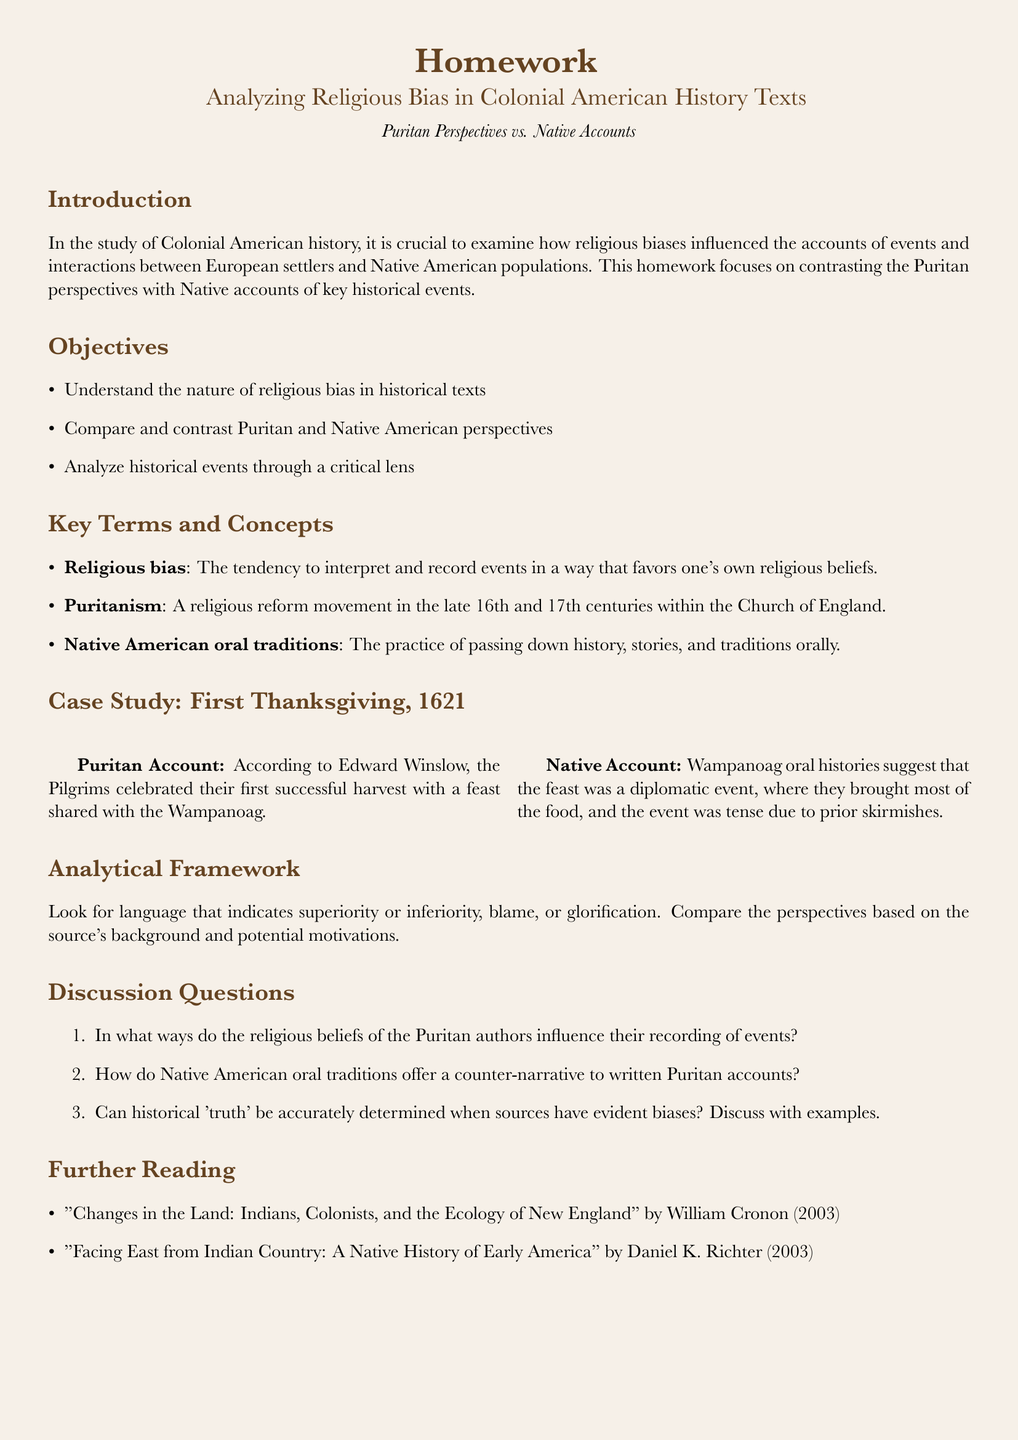What is the title of the homework? The title of the homework is presented at the top of the document, summarizing its focus on analyzing religious bias in historical texts.
Answer: Analyzing Religious Bias in Colonial American History Texts Who is the author of the Puritan account of the First Thanksgiving? The document specifies Edward Winslow as the author of the Puritan account regarding the First Thanksgiving.
Answer: Edward Winslow What year did the First Thanksgiving take place? The document clearly states that the First Thanksgiving occurred in the year 1621.
Answer: 1621 What is one key term defined in the document? The document provides definitions for key terms such as 'religious bias,' which highlights its significance in historical interpretation.
Answer: Religious bias How do Native American oral traditions function in contrast to Puritan accounts? The document describes Native American oral traditions as offering a counter-narrative to the written Puritan accounts, emphasizing different perspectives.
Answer: Counter-narrative What are the two perspectives compared in the case study? The case study elaborates on contrasting viewpoints between the Puritan account and Native American oral histories regarding the First Thanksgiving.
Answer: Puritan and Native American What is one objective of the homework? The document lists multiple objectives, one of which is to understand the nature of religious bias in historical texts.
Answer: Understand the nature of religious bias Name one author listed in the further reading section. The further reading section provides titles and authors, one of whom is William Cronon, contributing to the understanding of colonial history.
Answer: William Cronon 